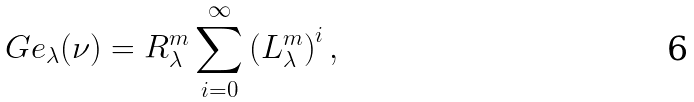Convert formula to latex. <formula><loc_0><loc_0><loc_500><loc_500>\ G e _ { \lambda } ( \nu ) = R ^ { m } _ { \lambda } \sum ^ { \infty } _ { i = 0 } \left ( L ^ { m } _ { \lambda } \right ) ^ { i } ,</formula> 